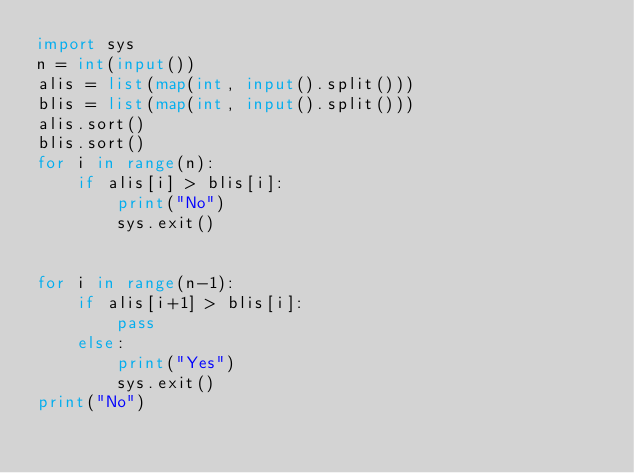<code> <loc_0><loc_0><loc_500><loc_500><_Python_>import sys
n = int(input())
alis = list(map(int, input().split()))
blis = list(map(int, input().split()))
alis.sort()
blis.sort()
for i in range(n):
    if alis[i] > blis[i]:
        print("No")
        sys.exit()


for i in range(n-1):
    if alis[i+1] > blis[i]:
        pass
    else:
        print("Yes")
        sys.exit()
print("No")
</code> 